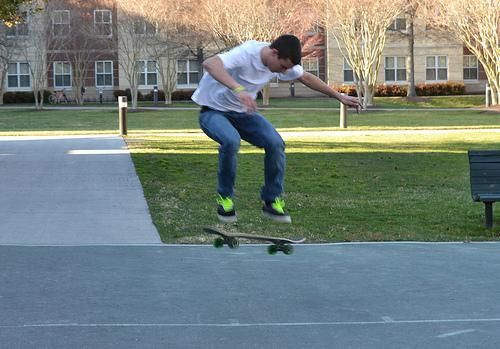Describe the man's outfit in the image while including his actions. Man wearing blue jeans, a white tee shirt, sneakers with green laces, and a yellow wristband is skillfully jumping on a skateboard. Mention the key elements in the scene and the main action taking place. Man jumping on skateboard, wearing blue jeans, white tee shirt, blue sneakers with green laces, yellow wristband, park bench, tree, and windows on the building. Write a succinct description of the main subject and what they are doing. Man in casual clothing, including blue shoes with green laces, jumps on a skateboard in mid-air. Give a concise description of the main subject and their surroundings. A man performing a skateboard trick in mid-air, wearing casual attire, is surrounded by a park setting and a building with several windows. Briefly describe the main action in the image and the subject's appearance. A man with dark brown hair wearing casual clothes is jumping on a skateboard in mid-air. What is the focus of the image, and what else is present in the scene? A skateboarder performing a trick, with a bench, leafless tree, and a building with windows in the background. Provide a brief account of the image's main subject and their surroundings. A man performing a skateboard jump is surrounded by a park bench, a tree, and a building with multiple windows. Combine the primary subject's action with a brief description of the scene. Man doing a skateboard trick up in the air, surrounded by a park bench, tree with no leaves, and a building with four windows. Concisely describe the primary subject's attire and actions while providing some context. Skateboarder in blue jeans and white tee shirt jumps off his board, near a park bench and a leafless tree. Mention the central subject performing an action, along with their attire. A man in blue jeans and a white tee shirt is executing an impressive skateboard trick in the air. 